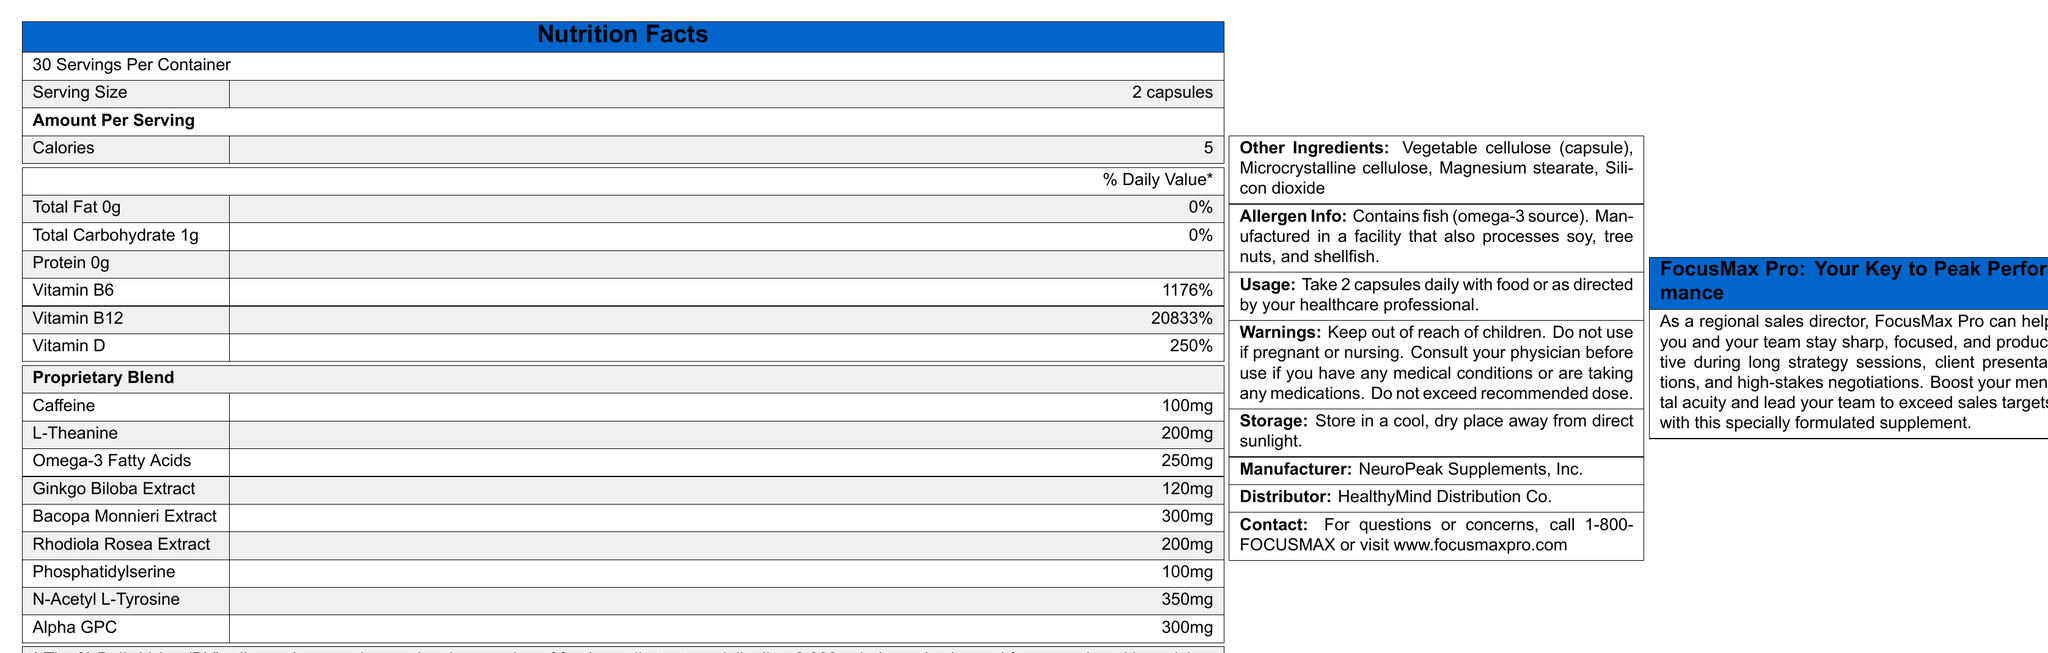what is the serving size of FocusMax Pro? The document states that the serving size is 2 capsules.
Answer: 2 capsules how many servings are in each container of FocusMax Pro? The document clearly states that there are 30 servings per container.
Answer: 30 servings what is the amount of calories per serving? The document lists the calorie content as 5 calories per serving.
Answer: 5 calories how should FocusMax Pro be stored? The storage instructions in the document specify to store it in a cool, dry place away from direct sunlight.
Answer: In a cool, dry place away from direct sunlight. what are the non-active ingredients in FocusMax Pro? The document lists these as the "Other Ingredients".
Answer: Vegetable cellulose (capsule), Microcrystalline cellulose, Magnesium stearate, Silicon dioxide which ingredient in FocusMax Pro is used for mental focus and clarity? A. Ginkgo Biloba Extract B. Bacopa Monnieri Extract C. Caffeine D. All of the above Mental focus and clarity are generally boosted by Ginkgo Biloba Extract, Bacopa Monnieri Extract, and Caffeine, all of which are included in the ingredient list in the document.
Answer: D. All of the above which vitamin has the highest daily value percentage in FocusMax Pro? A. Vitamin B6 B. Vitamin B12 C. Vitamin D The document lists Vitamin B12 as having a daily value of 20833%, which is the highest compared to the other vitamins listed.
Answer: B. Vitamin B12 does FocusMax Pro contain allergens? The allergen information indicates that the product contains fish (omega-3 source) and is manufactured in a facility that also processes soy, tree nuts, and shellfish.
Answer: Yes should pregnant women use FocusMax Pro? The warning section advises against using the product if pregnant or nursing.
Answer: No how many milligrams of N-Acetyl L-Tyrosine are in each serving of FocusMax Pro? The proprietary blend section lists N-Acetyl L-Tyrosine as having 350mg per serving.
Answer: 350mg summarize the main idea of the document. The document outlines the nutritional content, instructions for use, allergen warnings, and benefits of the product, emphasizing its suitability for enhancing mental performance.
Answer: FocusMax Pro is a vitamin supplement designed to boost mental focus and productivity, containing a range of ingredients like vitamins, herbal extracts, and other compounds. It provides nutritional information, usage instructions, allergen info, and warnings, aiming to enhance performance for professionals. how much caffeine is in each serving of FocusMax Pro? The document specifies that each serving contains 100mg of caffeine.
Answer: 100mg is FocusMax Pro suitable for children? The document warns to keep the product out of reach of children.
Answer: No how much omega-3 fatty acids does each serving of FocusMax Pro contain in milligrams? The document states that each serving contains 250mg of omega-3 fatty acids.
Answer: 250mg who distributes FocusMax Pro? The contact section of the document states that FocusMax Pro is distributed by HealthyMind Distribution Co.
Answer: HealthyMind Distribution Co. what time of day should FocusMax Pro be taken? The document provides usage instructions but does not specify the time of day the product should be taken.
Answer: Not enough information 